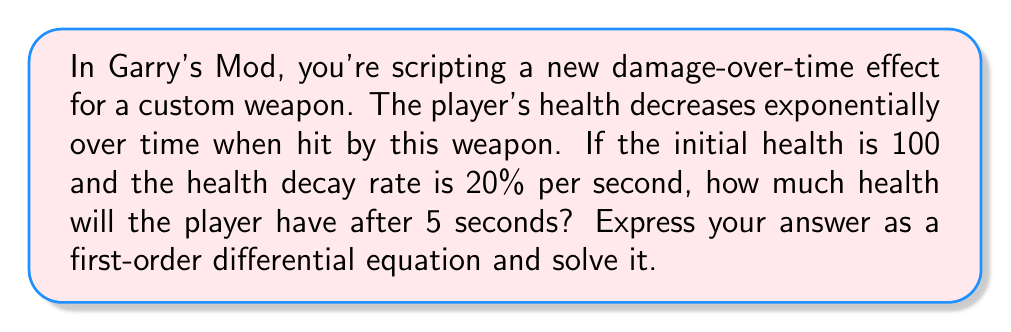Show me your answer to this math problem. Let's approach this step-by-step:

1) First, we need to set up our differential equation. Let $H(t)$ be the player's health at time $t$.

2) The rate of change of health is proportional to the current health, with a decay rate of 20% per second. This can be expressed as:

   $$\frac{dH}{dt} = -0.2H$$

3) This is a first-order linear differential equation. The general solution for this type of equation is:

   $$H(t) = Ce^{-0.2t}$$

   where $C$ is a constant we need to determine.

4) We know the initial condition: at $t=0$, $H(0) = 100$. Let's use this to find $C$:

   $$100 = Ce^{-0.2(0)} = C$$

5) So our specific solution is:

   $$H(t) = 100e^{-0.2t}$$

6) Now, we want to find $H(5)$:

   $$H(5) = 100e^{-0.2(5)} = 100e^{-1} \approx 36.79$$

Therefore, after 5 seconds, the player will have approximately 36.79 health.

In Lua script for Garry's Mod, you could implement this as:

```lua
function calculateHealth(initialHealth, decayRate, time)
    return initialHealth * math.exp(-decayRate * time)
end

local health = calculateHealth(100, 0.2, 5)
print("Player health after 5 seconds:", health)
```
Answer: The player's health after 5 seconds will be approximately 36.79, given by the equation $H(t) = 100e^{-0.2t}$ evaluated at $t=5$. 